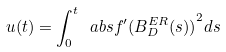<formula> <loc_0><loc_0><loc_500><loc_500>u ( t ) = \int _ { 0 } ^ { t } \ a b s { f ^ { \prime } ( B ^ { E R } _ { D } ( s ) ) } ^ { 2 } d s</formula> 